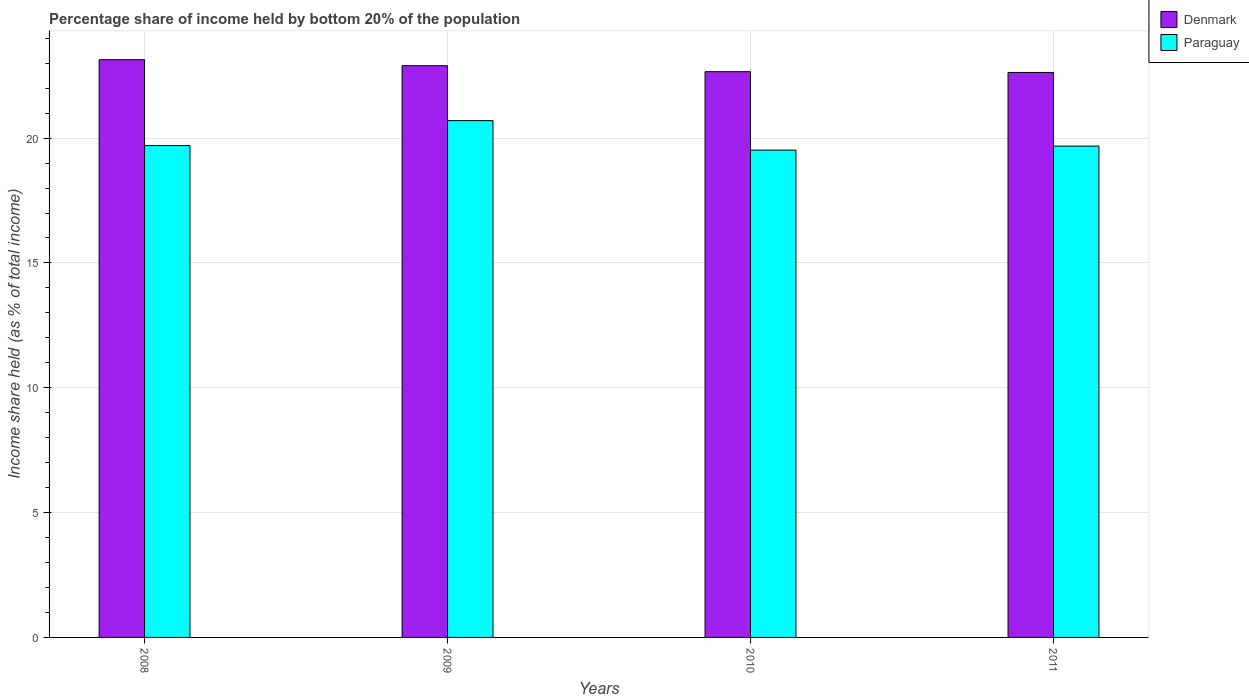Are the number of bars on each tick of the X-axis equal?
Your answer should be very brief. Yes. In how many cases, is the number of bars for a given year not equal to the number of legend labels?
Provide a succinct answer. 0. What is the share of income held by bottom 20% of the population in Denmark in 2008?
Provide a succinct answer. 23.14. Across all years, what is the maximum share of income held by bottom 20% of the population in Denmark?
Make the answer very short. 23.14. Across all years, what is the minimum share of income held by bottom 20% of the population in Paraguay?
Make the answer very short. 19.52. In which year was the share of income held by bottom 20% of the population in Denmark maximum?
Give a very brief answer. 2008. In which year was the share of income held by bottom 20% of the population in Denmark minimum?
Your response must be concise. 2011. What is the total share of income held by bottom 20% of the population in Paraguay in the graph?
Give a very brief answer. 79.6. What is the difference between the share of income held by bottom 20% of the population in Denmark in 2010 and that in 2011?
Keep it short and to the point. 0.03. What is the difference between the share of income held by bottom 20% of the population in Paraguay in 2008 and the share of income held by bottom 20% of the population in Denmark in 2010?
Ensure brevity in your answer.  -2.96. What is the average share of income held by bottom 20% of the population in Denmark per year?
Your response must be concise. 22.83. In the year 2011, what is the difference between the share of income held by bottom 20% of the population in Paraguay and share of income held by bottom 20% of the population in Denmark?
Ensure brevity in your answer.  -2.95. In how many years, is the share of income held by bottom 20% of the population in Paraguay greater than 16 %?
Provide a short and direct response. 4. What is the ratio of the share of income held by bottom 20% of the population in Paraguay in 2009 to that in 2010?
Your response must be concise. 1.06. Is the share of income held by bottom 20% of the population in Paraguay in 2010 less than that in 2011?
Your response must be concise. Yes. Is the difference between the share of income held by bottom 20% of the population in Paraguay in 2008 and 2009 greater than the difference between the share of income held by bottom 20% of the population in Denmark in 2008 and 2009?
Your answer should be very brief. No. What is the difference between the highest and the lowest share of income held by bottom 20% of the population in Denmark?
Offer a very short reply. 0.51. What does the 2nd bar from the left in 2009 represents?
Give a very brief answer. Paraguay. What does the 2nd bar from the right in 2011 represents?
Offer a very short reply. Denmark. How many bars are there?
Your response must be concise. 8. Are all the bars in the graph horizontal?
Your answer should be compact. No. What is the difference between two consecutive major ticks on the Y-axis?
Provide a short and direct response. 5. Does the graph contain grids?
Your answer should be compact. Yes. Where does the legend appear in the graph?
Provide a short and direct response. Top right. How many legend labels are there?
Your response must be concise. 2. What is the title of the graph?
Your answer should be very brief. Percentage share of income held by bottom 20% of the population. Does "South Sudan" appear as one of the legend labels in the graph?
Provide a succinct answer. No. What is the label or title of the X-axis?
Your response must be concise. Years. What is the label or title of the Y-axis?
Make the answer very short. Income share held (as % of total income). What is the Income share held (as % of total income) of Denmark in 2008?
Keep it short and to the point. 23.14. What is the Income share held (as % of total income) in Denmark in 2009?
Keep it short and to the point. 22.9. What is the Income share held (as % of total income) in Paraguay in 2009?
Your response must be concise. 20.7. What is the Income share held (as % of total income) of Denmark in 2010?
Offer a very short reply. 22.66. What is the Income share held (as % of total income) in Paraguay in 2010?
Offer a very short reply. 19.52. What is the Income share held (as % of total income) in Denmark in 2011?
Ensure brevity in your answer.  22.63. What is the Income share held (as % of total income) of Paraguay in 2011?
Offer a very short reply. 19.68. Across all years, what is the maximum Income share held (as % of total income) in Denmark?
Your answer should be compact. 23.14. Across all years, what is the maximum Income share held (as % of total income) in Paraguay?
Provide a succinct answer. 20.7. Across all years, what is the minimum Income share held (as % of total income) in Denmark?
Ensure brevity in your answer.  22.63. Across all years, what is the minimum Income share held (as % of total income) of Paraguay?
Provide a short and direct response. 19.52. What is the total Income share held (as % of total income) in Denmark in the graph?
Ensure brevity in your answer.  91.33. What is the total Income share held (as % of total income) of Paraguay in the graph?
Offer a very short reply. 79.6. What is the difference between the Income share held (as % of total income) in Denmark in 2008 and that in 2009?
Your answer should be very brief. 0.24. What is the difference between the Income share held (as % of total income) in Paraguay in 2008 and that in 2009?
Make the answer very short. -1. What is the difference between the Income share held (as % of total income) of Denmark in 2008 and that in 2010?
Keep it short and to the point. 0.48. What is the difference between the Income share held (as % of total income) of Paraguay in 2008 and that in 2010?
Provide a succinct answer. 0.18. What is the difference between the Income share held (as % of total income) in Denmark in 2008 and that in 2011?
Provide a succinct answer. 0.51. What is the difference between the Income share held (as % of total income) of Paraguay in 2008 and that in 2011?
Offer a terse response. 0.02. What is the difference between the Income share held (as % of total income) of Denmark in 2009 and that in 2010?
Make the answer very short. 0.24. What is the difference between the Income share held (as % of total income) of Paraguay in 2009 and that in 2010?
Offer a terse response. 1.18. What is the difference between the Income share held (as % of total income) in Denmark in 2009 and that in 2011?
Your answer should be compact. 0.27. What is the difference between the Income share held (as % of total income) in Paraguay in 2009 and that in 2011?
Provide a short and direct response. 1.02. What is the difference between the Income share held (as % of total income) of Paraguay in 2010 and that in 2011?
Offer a very short reply. -0.16. What is the difference between the Income share held (as % of total income) of Denmark in 2008 and the Income share held (as % of total income) of Paraguay in 2009?
Keep it short and to the point. 2.44. What is the difference between the Income share held (as % of total income) of Denmark in 2008 and the Income share held (as % of total income) of Paraguay in 2010?
Ensure brevity in your answer.  3.62. What is the difference between the Income share held (as % of total income) of Denmark in 2008 and the Income share held (as % of total income) of Paraguay in 2011?
Provide a succinct answer. 3.46. What is the difference between the Income share held (as % of total income) of Denmark in 2009 and the Income share held (as % of total income) of Paraguay in 2010?
Give a very brief answer. 3.38. What is the difference between the Income share held (as % of total income) of Denmark in 2009 and the Income share held (as % of total income) of Paraguay in 2011?
Your answer should be compact. 3.22. What is the difference between the Income share held (as % of total income) of Denmark in 2010 and the Income share held (as % of total income) of Paraguay in 2011?
Your answer should be very brief. 2.98. What is the average Income share held (as % of total income) in Denmark per year?
Provide a short and direct response. 22.83. What is the average Income share held (as % of total income) in Paraguay per year?
Your response must be concise. 19.9. In the year 2008, what is the difference between the Income share held (as % of total income) of Denmark and Income share held (as % of total income) of Paraguay?
Make the answer very short. 3.44. In the year 2010, what is the difference between the Income share held (as % of total income) of Denmark and Income share held (as % of total income) of Paraguay?
Your answer should be compact. 3.14. In the year 2011, what is the difference between the Income share held (as % of total income) in Denmark and Income share held (as % of total income) in Paraguay?
Offer a terse response. 2.95. What is the ratio of the Income share held (as % of total income) in Denmark in 2008 to that in 2009?
Offer a very short reply. 1.01. What is the ratio of the Income share held (as % of total income) of Paraguay in 2008 to that in 2009?
Keep it short and to the point. 0.95. What is the ratio of the Income share held (as % of total income) in Denmark in 2008 to that in 2010?
Offer a very short reply. 1.02. What is the ratio of the Income share held (as % of total income) in Paraguay in 2008 to that in 2010?
Give a very brief answer. 1.01. What is the ratio of the Income share held (as % of total income) of Denmark in 2008 to that in 2011?
Keep it short and to the point. 1.02. What is the ratio of the Income share held (as % of total income) in Paraguay in 2008 to that in 2011?
Your answer should be very brief. 1. What is the ratio of the Income share held (as % of total income) in Denmark in 2009 to that in 2010?
Provide a short and direct response. 1.01. What is the ratio of the Income share held (as % of total income) of Paraguay in 2009 to that in 2010?
Give a very brief answer. 1.06. What is the ratio of the Income share held (as % of total income) in Denmark in 2009 to that in 2011?
Offer a very short reply. 1.01. What is the ratio of the Income share held (as % of total income) of Paraguay in 2009 to that in 2011?
Your answer should be compact. 1.05. What is the ratio of the Income share held (as % of total income) of Denmark in 2010 to that in 2011?
Your answer should be very brief. 1. What is the difference between the highest and the second highest Income share held (as % of total income) of Denmark?
Your answer should be compact. 0.24. What is the difference between the highest and the second highest Income share held (as % of total income) in Paraguay?
Make the answer very short. 1. What is the difference between the highest and the lowest Income share held (as % of total income) in Denmark?
Make the answer very short. 0.51. What is the difference between the highest and the lowest Income share held (as % of total income) in Paraguay?
Make the answer very short. 1.18. 